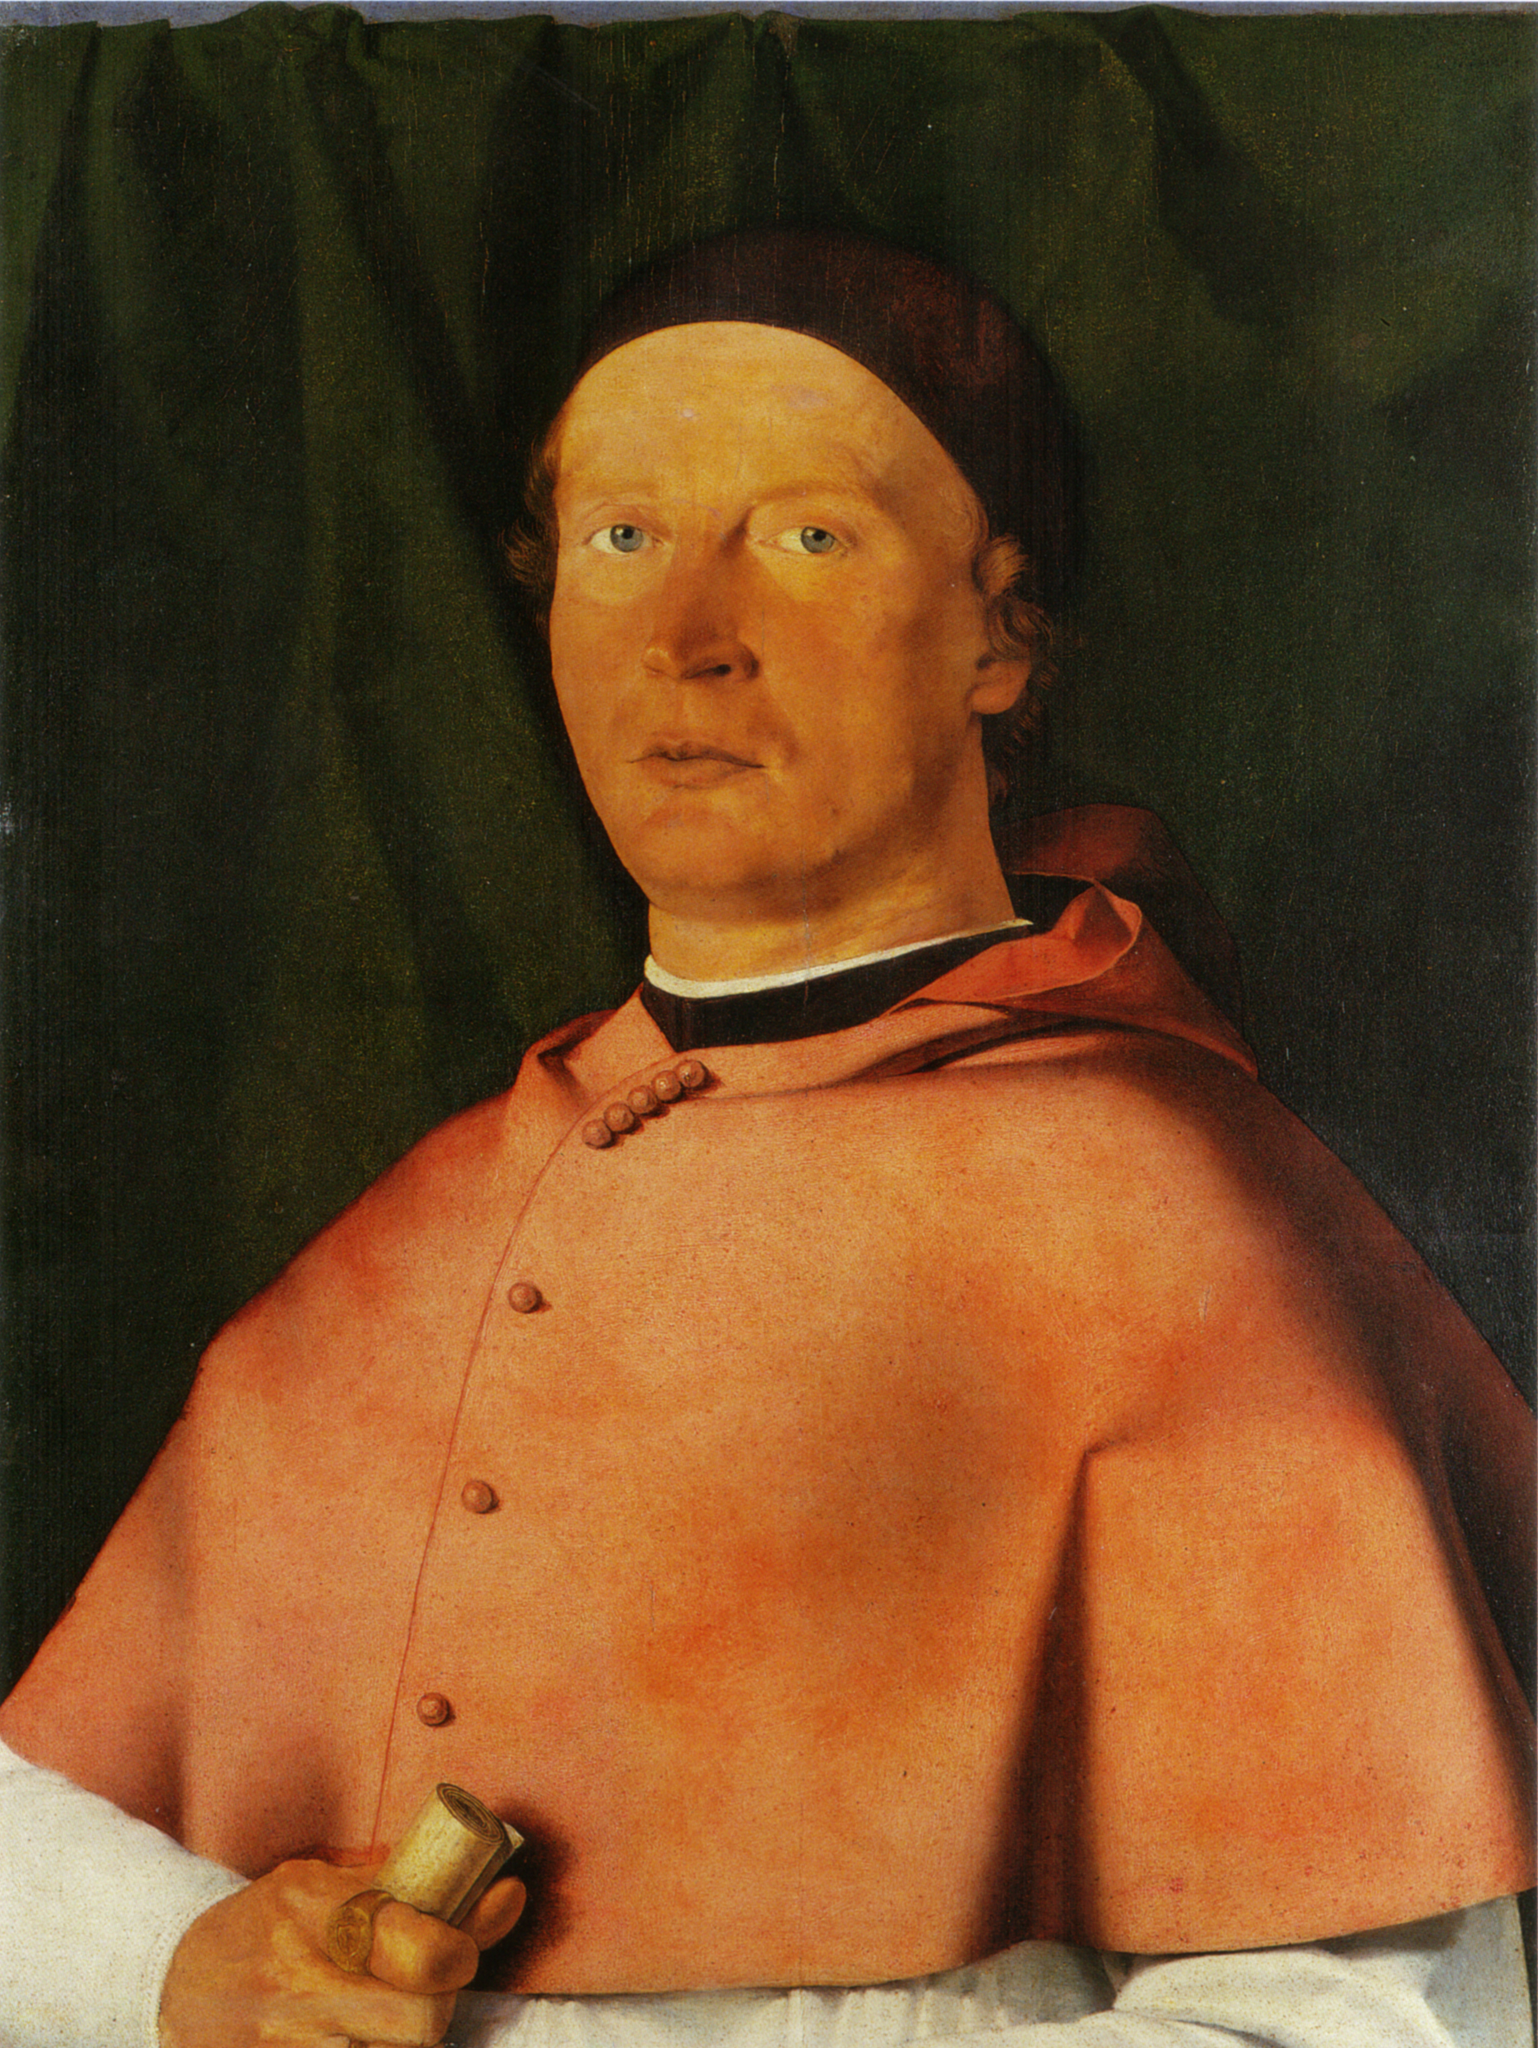Can you tell me about the historical context of this painting? This portrait resembles works from the Northern Renaissance, likely dating back to the 15th or early 16th century. The era was marked by a focus on realism and individualism, as artists strove to capture the unique qualities of their subjects. The clothing suggests he may have been a person of influence, possibly linked to the ecclesiastical or civic institutions of the time. This period was characterized by significant developments in art, with an increased interest in humanism and the detailed representation of subjects. 